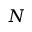<formula> <loc_0><loc_0><loc_500><loc_500>N</formula> 